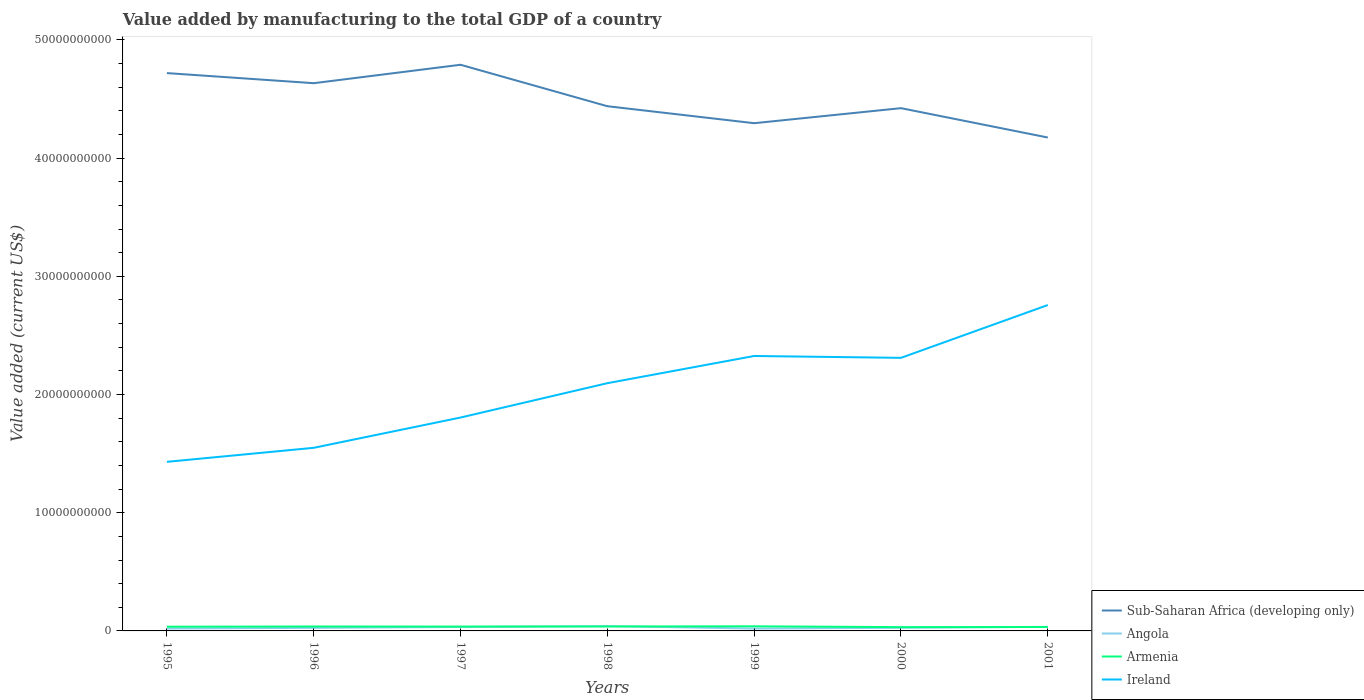Does the line corresponding to Armenia intersect with the line corresponding to Ireland?
Give a very brief answer. No. Across all years, what is the maximum value added by manufacturing to the total GDP in Sub-Saharan Africa (developing only)?
Your response must be concise. 4.17e+1. In which year was the value added by manufacturing to the total GDP in Sub-Saharan Africa (developing only) maximum?
Your answer should be compact. 2001. What is the total value added by manufacturing to the total GDP in Angola in the graph?
Keep it short and to the point. -5.66e+07. What is the difference between the highest and the second highest value added by manufacturing to the total GDP in Sub-Saharan Africa (developing only)?
Provide a succinct answer. 6.16e+09. Is the value added by manufacturing to the total GDP in Angola strictly greater than the value added by manufacturing to the total GDP in Armenia over the years?
Keep it short and to the point. No. How many years are there in the graph?
Give a very brief answer. 7. Does the graph contain any zero values?
Give a very brief answer. No. Does the graph contain grids?
Provide a short and direct response. No. How many legend labels are there?
Offer a terse response. 4. What is the title of the graph?
Your answer should be very brief. Value added by manufacturing to the total GDP of a country. What is the label or title of the Y-axis?
Give a very brief answer. Value added (current US$). What is the Value added (current US$) of Sub-Saharan Africa (developing only) in 1995?
Ensure brevity in your answer.  4.72e+1. What is the Value added (current US$) in Angola in 1995?
Provide a short and direct response. 2.03e+08. What is the Value added (current US$) of Armenia in 1995?
Your answer should be very brief. 3.56e+08. What is the Value added (current US$) in Ireland in 1995?
Keep it short and to the point. 1.43e+1. What is the Value added (current US$) in Sub-Saharan Africa (developing only) in 1996?
Your answer should be compact. 4.63e+1. What is the Value added (current US$) in Angola in 1996?
Provide a short and direct response. 2.59e+08. What is the Value added (current US$) of Armenia in 1996?
Your answer should be very brief. 3.74e+08. What is the Value added (current US$) of Ireland in 1996?
Offer a very short reply. 1.55e+1. What is the Value added (current US$) in Sub-Saharan Africa (developing only) in 1997?
Offer a terse response. 4.79e+1. What is the Value added (current US$) in Angola in 1997?
Provide a short and direct response. 3.35e+08. What is the Value added (current US$) in Armenia in 1997?
Keep it short and to the point. 3.68e+08. What is the Value added (current US$) of Ireland in 1997?
Ensure brevity in your answer.  1.81e+1. What is the Value added (current US$) of Sub-Saharan Africa (developing only) in 1998?
Give a very brief answer. 4.44e+1. What is the Value added (current US$) of Angola in 1998?
Offer a terse response. 4.07e+08. What is the Value added (current US$) of Armenia in 1998?
Keep it short and to the point. 3.77e+08. What is the Value added (current US$) of Ireland in 1998?
Give a very brief answer. 2.10e+1. What is the Value added (current US$) of Sub-Saharan Africa (developing only) in 1999?
Offer a terse response. 4.30e+1. What is the Value added (current US$) of Angola in 1999?
Give a very brief answer. 1.98e+08. What is the Value added (current US$) in Armenia in 1999?
Your response must be concise. 3.90e+08. What is the Value added (current US$) of Ireland in 1999?
Your response must be concise. 2.33e+1. What is the Value added (current US$) of Sub-Saharan Africa (developing only) in 2000?
Keep it short and to the point. 4.42e+1. What is the Value added (current US$) in Angola in 2000?
Offer a very short reply. 2.64e+08. What is the Value added (current US$) of Armenia in 2000?
Make the answer very short. 3.22e+08. What is the Value added (current US$) of Ireland in 2000?
Make the answer very short. 2.31e+1. What is the Value added (current US$) of Sub-Saharan Africa (developing only) in 2001?
Offer a terse response. 4.17e+1. What is the Value added (current US$) in Angola in 2001?
Offer a very short reply. 3.46e+08. What is the Value added (current US$) in Armenia in 2001?
Keep it short and to the point. 3.32e+08. What is the Value added (current US$) in Ireland in 2001?
Provide a short and direct response. 2.76e+1. Across all years, what is the maximum Value added (current US$) of Sub-Saharan Africa (developing only)?
Offer a very short reply. 4.79e+1. Across all years, what is the maximum Value added (current US$) of Angola?
Offer a very short reply. 4.07e+08. Across all years, what is the maximum Value added (current US$) in Armenia?
Provide a succinct answer. 3.90e+08. Across all years, what is the maximum Value added (current US$) of Ireland?
Keep it short and to the point. 2.76e+1. Across all years, what is the minimum Value added (current US$) in Sub-Saharan Africa (developing only)?
Give a very brief answer. 4.17e+1. Across all years, what is the minimum Value added (current US$) of Angola?
Your answer should be compact. 1.98e+08. Across all years, what is the minimum Value added (current US$) of Armenia?
Your response must be concise. 3.22e+08. Across all years, what is the minimum Value added (current US$) of Ireland?
Provide a short and direct response. 1.43e+1. What is the total Value added (current US$) of Sub-Saharan Africa (developing only) in the graph?
Offer a very short reply. 3.15e+11. What is the total Value added (current US$) of Angola in the graph?
Ensure brevity in your answer.  2.01e+09. What is the total Value added (current US$) in Armenia in the graph?
Your response must be concise. 2.52e+09. What is the total Value added (current US$) of Ireland in the graph?
Ensure brevity in your answer.  1.43e+11. What is the difference between the Value added (current US$) of Sub-Saharan Africa (developing only) in 1995 and that in 1996?
Provide a succinct answer. 8.54e+08. What is the difference between the Value added (current US$) of Angola in 1995 and that in 1996?
Make the answer very short. -5.66e+07. What is the difference between the Value added (current US$) in Armenia in 1995 and that in 1996?
Offer a terse response. -1.78e+07. What is the difference between the Value added (current US$) in Ireland in 1995 and that in 1996?
Your answer should be compact. -1.19e+09. What is the difference between the Value added (current US$) of Sub-Saharan Africa (developing only) in 1995 and that in 1997?
Offer a terse response. -7.05e+08. What is the difference between the Value added (current US$) in Angola in 1995 and that in 1997?
Offer a terse response. -1.32e+08. What is the difference between the Value added (current US$) of Armenia in 1995 and that in 1997?
Offer a very short reply. -1.19e+07. What is the difference between the Value added (current US$) of Ireland in 1995 and that in 1997?
Offer a terse response. -3.75e+09. What is the difference between the Value added (current US$) of Sub-Saharan Africa (developing only) in 1995 and that in 1998?
Ensure brevity in your answer.  2.80e+09. What is the difference between the Value added (current US$) of Angola in 1995 and that in 1998?
Ensure brevity in your answer.  -2.04e+08. What is the difference between the Value added (current US$) in Armenia in 1995 and that in 1998?
Keep it short and to the point. -2.03e+07. What is the difference between the Value added (current US$) of Ireland in 1995 and that in 1998?
Offer a terse response. -6.65e+09. What is the difference between the Value added (current US$) of Sub-Saharan Africa (developing only) in 1995 and that in 1999?
Keep it short and to the point. 4.24e+09. What is the difference between the Value added (current US$) in Angola in 1995 and that in 1999?
Provide a short and direct response. 4.48e+06. What is the difference between the Value added (current US$) of Armenia in 1995 and that in 1999?
Provide a succinct answer. -3.41e+07. What is the difference between the Value added (current US$) in Ireland in 1995 and that in 1999?
Offer a very short reply. -8.96e+09. What is the difference between the Value added (current US$) of Sub-Saharan Africa (developing only) in 1995 and that in 2000?
Your answer should be compact. 2.97e+09. What is the difference between the Value added (current US$) in Angola in 1995 and that in 2000?
Offer a terse response. -6.11e+07. What is the difference between the Value added (current US$) in Armenia in 1995 and that in 2000?
Ensure brevity in your answer.  3.45e+07. What is the difference between the Value added (current US$) of Ireland in 1995 and that in 2000?
Provide a succinct answer. -8.80e+09. What is the difference between the Value added (current US$) of Sub-Saharan Africa (developing only) in 1995 and that in 2001?
Your answer should be compact. 5.45e+09. What is the difference between the Value added (current US$) of Angola in 1995 and that in 2001?
Make the answer very short. -1.43e+08. What is the difference between the Value added (current US$) of Armenia in 1995 and that in 2001?
Provide a short and direct response. 2.42e+07. What is the difference between the Value added (current US$) in Ireland in 1995 and that in 2001?
Keep it short and to the point. -1.33e+1. What is the difference between the Value added (current US$) of Sub-Saharan Africa (developing only) in 1996 and that in 1997?
Provide a succinct answer. -1.56e+09. What is the difference between the Value added (current US$) of Angola in 1996 and that in 1997?
Your response must be concise. -7.56e+07. What is the difference between the Value added (current US$) in Armenia in 1996 and that in 1997?
Your answer should be compact. 5.88e+06. What is the difference between the Value added (current US$) in Ireland in 1996 and that in 1997?
Give a very brief answer. -2.56e+09. What is the difference between the Value added (current US$) in Sub-Saharan Africa (developing only) in 1996 and that in 1998?
Give a very brief answer. 1.95e+09. What is the difference between the Value added (current US$) in Angola in 1996 and that in 1998?
Ensure brevity in your answer.  -1.48e+08. What is the difference between the Value added (current US$) of Armenia in 1996 and that in 1998?
Offer a very short reply. -2.52e+06. What is the difference between the Value added (current US$) of Ireland in 1996 and that in 1998?
Provide a short and direct response. -5.47e+09. What is the difference between the Value added (current US$) in Sub-Saharan Africa (developing only) in 1996 and that in 1999?
Make the answer very short. 3.38e+09. What is the difference between the Value added (current US$) of Angola in 1996 and that in 1999?
Offer a very short reply. 6.11e+07. What is the difference between the Value added (current US$) in Armenia in 1996 and that in 1999?
Your response must be concise. -1.63e+07. What is the difference between the Value added (current US$) of Ireland in 1996 and that in 1999?
Keep it short and to the point. -7.77e+09. What is the difference between the Value added (current US$) in Sub-Saharan Africa (developing only) in 1996 and that in 2000?
Provide a succinct answer. 2.11e+09. What is the difference between the Value added (current US$) in Angola in 1996 and that in 2000?
Offer a very short reply. -4.50e+06. What is the difference between the Value added (current US$) of Armenia in 1996 and that in 2000?
Your answer should be very brief. 5.23e+07. What is the difference between the Value added (current US$) of Ireland in 1996 and that in 2000?
Your response must be concise. -7.61e+09. What is the difference between the Value added (current US$) of Sub-Saharan Africa (developing only) in 1996 and that in 2001?
Offer a terse response. 4.60e+09. What is the difference between the Value added (current US$) in Angola in 1996 and that in 2001?
Your answer should be compact. -8.67e+07. What is the difference between the Value added (current US$) in Armenia in 1996 and that in 2001?
Provide a short and direct response. 4.20e+07. What is the difference between the Value added (current US$) in Ireland in 1996 and that in 2001?
Your response must be concise. -1.21e+1. What is the difference between the Value added (current US$) in Sub-Saharan Africa (developing only) in 1997 and that in 1998?
Ensure brevity in your answer.  3.51e+09. What is the difference between the Value added (current US$) of Angola in 1997 and that in 1998?
Your answer should be very brief. -7.23e+07. What is the difference between the Value added (current US$) of Armenia in 1997 and that in 1998?
Your answer should be very brief. -8.41e+06. What is the difference between the Value added (current US$) of Ireland in 1997 and that in 1998?
Offer a terse response. -2.91e+09. What is the difference between the Value added (current US$) in Sub-Saharan Africa (developing only) in 1997 and that in 1999?
Provide a short and direct response. 4.94e+09. What is the difference between the Value added (current US$) in Angola in 1997 and that in 1999?
Your response must be concise. 1.37e+08. What is the difference between the Value added (current US$) of Armenia in 1997 and that in 1999?
Your answer should be very brief. -2.22e+07. What is the difference between the Value added (current US$) of Ireland in 1997 and that in 1999?
Make the answer very short. -5.21e+09. What is the difference between the Value added (current US$) in Sub-Saharan Africa (developing only) in 1997 and that in 2000?
Offer a terse response. 3.67e+09. What is the difference between the Value added (current US$) in Angola in 1997 and that in 2000?
Offer a very short reply. 7.11e+07. What is the difference between the Value added (current US$) in Armenia in 1997 and that in 2000?
Your answer should be compact. 4.64e+07. What is the difference between the Value added (current US$) of Ireland in 1997 and that in 2000?
Keep it short and to the point. -5.05e+09. What is the difference between the Value added (current US$) in Sub-Saharan Africa (developing only) in 1997 and that in 2001?
Make the answer very short. 6.16e+09. What is the difference between the Value added (current US$) in Angola in 1997 and that in 2001?
Give a very brief answer. -1.12e+07. What is the difference between the Value added (current US$) of Armenia in 1997 and that in 2001?
Give a very brief answer. 3.61e+07. What is the difference between the Value added (current US$) of Ireland in 1997 and that in 2001?
Keep it short and to the point. -9.52e+09. What is the difference between the Value added (current US$) in Sub-Saharan Africa (developing only) in 1998 and that in 1999?
Your response must be concise. 1.44e+09. What is the difference between the Value added (current US$) of Angola in 1998 and that in 1999?
Your answer should be very brief. 2.09e+08. What is the difference between the Value added (current US$) in Armenia in 1998 and that in 1999?
Keep it short and to the point. -1.38e+07. What is the difference between the Value added (current US$) of Ireland in 1998 and that in 1999?
Your answer should be compact. -2.30e+09. What is the difference between the Value added (current US$) in Sub-Saharan Africa (developing only) in 1998 and that in 2000?
Make the answer very short. 1.66e+08. What is the difference between the Value added (current US$) in Angola in 1998 and that in 2000?
Your response must be concise. 1.43e+08. What is the difference between the Value added (current US$) in Armenia in 1998 and that in 2000?
Your answer should be compact. 5.48e+07. What is the difference between the Value added (current US$) of Ireland in 1998 and that in 2000?
Give a very brief answer. -2.14e+09. What is the difference between the Value added (current US$) of Sub-Saharan Africa (developing only) in 1998 and that in 2001?
Keep it short and to the point. 2.65e+09. What is the difference between the Value added (current US$) of Angola in 1998 and that in 2001?
Give a very brief answer. 6.12e+07. What is the difference between the Value added (current US$) of Armenia in 1998 and that in 2001?
Your answer should be compact. 4.45e+07. What is the difference between the Value added (current US$) of Ireland in 1998 and that in 2001?
Offer a terse response. -6.61e+09. What is the difference between the Value added (current US$) of Sub-Saharan Africa (developing only) in 1999 and that in 2000?
Offer a terse response. -1.27e+09. What is the difference between the Value added (current US$) in Angola in 1999 and that in 2000?
Your response must be concise. -6.56e+07. What is the difference between the Value added (current US$) of Armenia in 1999 and that in 2000?
Make the answer very short. 6.86e+07. What is the difference between the Value added (current US$) in Ireland in 1999 and that in 2000?
Your answer should be compact. 1.57e+08. What is the difference between the Value added (current US$) of Sub-Saharan Africa (developing only) in 1999 and that in 2001?
Ensure brevity in your answer.  1.21e+09. What is the difference between the Value added (current US$) in Angola in 1999 and that in 2001?
Give a very brief answer. -1.48e+08. What is the difference between the Value added (current US$) of Armenia in 1999 and that in 2001?
Offer a terse response. 5.83e+07. What is the difference between the Value added (current US$) in Ireland in 1999 and that in 2001?
Make the answer very short. -4.31e+09. What is the difference between the Value added (current US$) in Sub-Saharan Africa (developing only) in 2000 and that in 2001?
Offer a terse response. 2.48e+09. What is the difference between the Value added (current US$) of Angola in 2000 and that in 2001?
Offer a terse response. -8.22e+07. What is the difference between the Value added (current US$) of Armenia in 2000 and that in 2001?
Keep it short and to the point. -1.03e+07. What is the difference between the Value added (current US$) of Ireland in 2000 and that in 2001?
Your answer should be very brief. -4.47e+09. What is the difference between the Value added (current US$) of Sub-Saharan Africa (developing only) in 1995 and the Value added (current US$) of Angola in 1996?
Your answer should be compact. 4.69e+1. What is the difference between the Value added (current US$) of Sub-Saharan Africa (developing only) in 1995 and the Value added (current US$) of Armenia in 1996?
Provide a succinct answer. 4.68e+1. What is the difference between the Value added (current US$) in Sub-Saharan Africa (developing only) in 1995 and the Value added (current US$) in Ireland in 1996?
Your answer should be very brief. 3.17e+1. What is the difference between the Value added (current US$) of Angola in 1995 and the Value added (current US$) of Armenia in 1996?
Give a very brief answer. -1.71e+08. What is the difference between the Value added (current US$) in Angola in 1995 and the Value added (current US$) in Ireland in 1996?
Your response must be concise. -1.53e+1. What is the difference between the Value added (current US$) in Armenia in 1995 and the Value added (current US$) in Ireland in 1996?
Your answer should be compact. -1.51e+1. What is the difference between the Value added (current US$) in Sub-Saharan Africa (developing only) in 1995 and the Value added (current US$) in Angola in 1997?
Provide a short and direct response. 4.69e+1. What is the difference between the Value added (current US$) in Sub-Saharan Africa (developing only) in 1995 and the Value added (current US$) in Armenia in 1997?
Give a very brief answer. 4.68e+1. What is the difference between the Value added (current US$) of Sub-Saharan Africa (developing only) in 1995 and the Value added (current US$) of Ireland in 1997?
Your response must be concise. 2.91e+1. What is the difference between the Value added (current US$) of Angola in 1995 and the Value added (current US$) of Armenia in 1997?
Make the answer very short. -1.65e+08. What is the difference between the Value added (current US$) of Angola in 1995 and the Value added (current US$) of Ireland in 1997?
Give a very brief answer. -1.79e+1. What is the difference between the Value added (current US$) in Armenia in 1995 and the Value added (current US$) in Ireland in 1997?
Provide a succinct answer. -1.77e+1. What is the difference between the Value added (current US$) of Sub-Saharan Africa (developing only) in 1995 and the Value added (current US$) of Angola in 1998?
Make the answer very short. 4.68e+1. What is the difference between the Value added (current US$) of Sub-Saharan Africa (developing only) in 1995 and the Value added (current US$) of Armenia in 1998?
Provide a short and direct response. 4.68e+1. What is the difference between the Value added (current US$) of Sub-Saharan Africa (developing only) in 1995 and the Value added (current US$) of Ireland in 1998?
Make the answer very short. 2.62e+1. What is the difference between the Value added (current US$) of Angola in 1995 and the Value added (current US$) of Armenia in 1998?
Keep it short and to the point. -1.74e+08. What is the difference between the Value added (current US$) in Angola in 1995 and the Value added (current US$) in Ireland in 1998?
Ensure brevity in your answer.  -2.08e+1. What is the difference between the Value added (current US$) of Armenia in 1995 and the Value added (current US$) of Ireland in 1998?
Give a very brief answer. -2.06e+1. What is the difference between the Value added (current US$) in Sub-Saharan Africa (developing only) in 1995 and the Value added (current US$) in Angola in 1999?
Offer a very short reply. 4.70e+1. What is the difference between the Value added (current US$) in Sub-Saharan Africa (developing only) in 1995 and the Value added (current US$) in Armenia in 1999?
Give a very brief answer. 4.68e+1. What is the difference between the Value added (current US$) in Sub-Saharan Africa (developing only) in 1995 and the Value added (current US$) in Ireland in 1999?
Your response must be concise. 2.39e+1. What is the difference between the Value added (current US$) of Angola in 1995 and the Value added (current US$) of Armenia in 1999?
Keep it short and to the point. -1.88e+08. What is the difference between the Value added (current US$) of Angola in 1995 and the Value added (current US$) of Ireland in 1999?
Provide a short and direct response. -2.31e+1. What is the difference between the Value added (current US$) in Armenia in 1995 and the Value added (current US$) in Ireland in 1999?
Keep it short and to the point. -2.29e+1. What is the difference between the Value added (current US$) in Sub-Saharan Africa (developing only) in 1995 and the Value added (current US$) in Angola in 2000?
Offer a very short reply. 4.69e+1. What is the difference between the Value added (current US$) in Sub-Saharan Africa (developing only) in 1995 and the Value added (current US$) in Armenia in 2000?
Ensure brevity in your answer.  4.69e+1. What is the difference between the Value added (current US$) in Sub-Saharan Africa (developing only) in 1995 and the Value added (current US$) in Ireland in 2000?
Ensure brevity in your answer.  2.41e+1. What is the difference between the Value added (current US$) in Angola in 1995 and the Value added (current US$) in Armenia in 2000?
Give a very brief answer. -1.19e+08. What is the difference between the Value added (current US$) of Angola in 1995 and the Value added (current US$) of Ireland in 2000?
Your answer should be very brief. -2.29e+1. What is the difference between the Value added (current US$) in Armenia in 1995 and the Value added (current US$) in Ireland in 2000?
Your answer should be compact. -2.27e+1. What is the difference between the Value added (current US$) in Sub-Saharan Africa (developing only) in 1995 and the Value added (current US$) in Angola in 2001?
Offer a very short reply. 4.69e+1. What is the difference between the Value added (current US$) in Sub-Saharan Africa (developing only) in 1995 and the Value added (current US$) in Armenia in 2001?
Offer a terse response. 4.69e+1. What is the difference between the Value added (current US$) in Sub-Saharan Africa (developing only) in 1995 and the Value added (current US$) in Ireland in 2001?
Make the answer very short. 1.96e+1. What is the difference between the Value added (current US$) of Angola in 1995 and the Value added (current US$) of Armenia in 2001?
Your response must be concise. -1.29e+08. What is the difference between the Value added (current US$) of Angola in 1995 and the Value added (current US$) of Ireland in 2001?
Provide a succinct answer. -2.74e+1. What is the difference between the Value added (current US$) in Armenia in 1995 and the Value added (current US$) in Ireland in 2001?
Your answer should be compact. -2.72e+1. What is the difference between the Value added (current US$) of Sub-Saharan Africa (developing only) in 1996 and the Value added (current US$) of Angola in 1997?
Offer a very short reply. 4.60e+1. What is the difference between the Value added (current US$) in Sub-Saharan Africa (developing only) in 1996 and the Value added (current US$) in Armenia in 1997?
Your response must be concise. 4.60e+1. What is the difference between the Value added (current US$) in Sub-Saharan Africa (developing only) in 1996 and the Value added (current US$) in Ireland in 1997?
Keep it short and to the point. 2.83e+1. What is the difference between the Value added (current US$) of Angola in 1996 and the Value added (current US$) of Armenia in 1997?
Offer a very short reply. -1.09e+08. What is the difference between the Value added (current US$) in Angola in 1996 and the Value added (current US$) in Ireland in 1997?
Your answer should be compact. -1.78e+1. What is the difference between the Value added (current US$) of Armenia in 1996 and the Value added (current US$) of Ireland in 1997?
Your response must be concise. -1.77e+1. What is the difference between the Value added (current US$) in Sub-Saharan Africa (developing only) in 1996 and the Value added (current US$) in Angola in 1998?
Offer a very short reply. 4.59e+1. What is the difference between the Value added (current US$) in Sub-Saharan Africa (developing only) in 1996 and the Value added (current US$) in Armenia in 1998?
Your answer should be very brief. 4.60e+1. What is the difference between the Value added (current US$) of Sub-Saharan Africa (developing only) in 1996 and the Value added (current US$) of Ireland in 1998?
Your response must be concise. 2.54e+1. What is the difference between the Value added (current US$) of Angola in 1996 and the Value added (current US$) of Armenia in 1998?
Keep it short and to the point. -1.17e+08. What is the difference between the Value added (current US$) in Angola in 1996 and the Value added (current US$) in Ireland in 1998?
Provide a short and direct response. -2.07e+1. What is the difference between the Value added (current US$) in Armenia in 1996 and the Value added (current US$) in Ireland in 1998?
Provide a short and direct response. -2.06e+1. What is the difference between the Value added (current US$) in Sub-Saharan Africa (developing only) in 1996 and the Value added (current US$) in Angola in 1999?
Provide a succinct answer. 4.61e+1. What is the difference between the Value added (current US$) of Sub-Saharan Africa (developing only) in 1996 and the Value added (current US$) of Armenia in 1999?
Your answer should be compact. 4.60e+1. What is the difference between the Value added (current US$) of Sub-Saharan Africa (developing only) in 1996 and the Value added (current US$) of Ireland in 1999?
Your response must be concise. 2.31e+1. What is the difference between the Value added (current US$) of Angola in 1996 and the Value added (current US$) of Armenia in 1999?
Your answer should be compact. -1.31e+08. What is the difference between the Value added (current US$) in Angola in 1996 and the Value added (current US$) in Ireland in 1999?
Provide a succinct answer. -2.30e+1. What is the difference between the Value added (current US$) in Armenia in 1996 and the Value added (current US$) in Ireland in 1999?
Your answer should be compact. -2.29e+1. What is the difference between the Value added (current US$) in Sub-Saharan Africa (developing only) in 1996 and the Value added (current US$) in Angola in 2000?
Your response must be concise. 4.61e+1. What is the difference between the Value added (current US$) of Sub-Saharan Africa (developing only) in 1996 and the Value added (current US$) of Armenia in 2000?
Keep it short and to the point. 4.60e+1. What is the difference between the Value added (current US$) of Sub-Saharan Africa (developing only) in 1996 and the Value added (current US$) of Ireland in 2000?
Offer a terse response. 2.32e+1. What is the difference between the Value added (current US$) in Angola in 1996 and the Value added (current US$) in Armenia in 2000?
Your answer should be very brief. -6.25e+07. What is the difference between the Value added (current US$) of Angola in 1996 and the Value added (current US$) of Ireland in 2000?
Provide a short and direct response. -2.28e+1. What is the difference between the Value added (current US$) in Armenia in 1996 and the Value added (current US$) in Ireland in 2000?
Provide a succinct answer. -2.27e+1. What is the difference between the Value added (current US$) of Sub-Saharan Africa (developing only) in 1996 and the Value added (current US$) of Angola in 2001?
Make the answer very short. 4.60e+1. What is the difference between the Value added (current US$) of Sub-Saharan Africa (developing only) in 1996 and the Value added (current US$) of Armenia in 2001?
Make the answer very short. 4.60e+1. What is the difference between the Value added (current US$) of Sub-Saharan Africa (developing only) in 1996 and the Value added (current US$) of Ireland in 2001?
Provide a succinct answer. 1.88e+1. What is the difference between the Value added (current US$) in Angola in 1996 and the Value added (current US$) in Armenia in 2001?
Offer a very short reply. -7.28e+07. What is the difference between the Value added (current US$) of Angola in 1996 and the Value added (current US$) of Ireland in 2001?
Offer a terse response. -2.73e+1. What is the difference between the Value added (current US$) of Armenia in 1996 and the Value added (current US$) of Ireland in 2001?
Offer a very short reply. -2.72e+1. What is the difference between the Value added (current US$) of Sub-Saharan Africa (developing only) in 1997 and the Value added (current US$) of Angola in 1998?
Your response must be concise. 4.75e+1. What is the difference between the Value added (current US$) of Sub-Saharan Africa (developing only) in 1997 and the Value added (current US$) of Armenia in 1998?
Make the answer very short. 4.75e+1. What is the difference between the Value added (current US$) in Sub-Saharan Africa (developing only) in 1997 and the Value added (current US$) in Ireland in 1998?
Your response must be concise. 2.69e+1. What is the difference between the Value added (current US$) of Angola in 1997 and the Value added (current US$) of Armenia in 1998?
Offer a terse response. -4.17e+07. What is the difference between the Value added (current US$) of Angola in 1997 and the Value added (current US$) of Ireland in 1998?
Make the answer very short. -2.06e+1. What is the difference between the Value added (current US$) of Armenia in 1997 and the Value added (current US$) of Ireland in 1998?
Your answer should be compact. -2.06e+1. What is the difference between the Value added (current US$) of Sub-Saharan Africa (developing only) in 1997 and the Value added (current US$) of Angola in 1999?
Your response must be concise. 4.77e+1. What is the difference between the Value added (current US$) of Sub-Saharan Africa (developing only) in 1997 and the Value added (current US$) of Armenia in 1999?
Keep it short and to the point. 4.75e+1. What is the difference between the Value added (current US$) in Sub-Saharan Africa (developing only) in 1997 and the Value added (current US$) in Ireland in 1999?
Your answer should be very brief. 2.46e+1. What is the difference between the Value added (current US$) of Angola in 1997 and the Value added (current US$) of Armenia in 1999?
Offer a very short reply. -5.55e+07. What is the difference between the Value added (current US$) of Angola in 1997 and the Value added (current US$) of Ireland in 1999?
Offer a terse response. -2.29e+1. What is the difference between the Value added (current US$) in Armenia in 1997 and the Value added (current US$) in Ireland in 1999?
Give a very brief answer. -2.29e+1. What is the difference between the Value added (current US$) in Sub-Saharan Africa (developing only) in 1997 and the Value added (current US$) in Angola in 2000?
Offer a terse response. 4.76e+1. What is the difference between the Value added (current US$) in Sub-Saharan Africa (developing only) in 1997 and the Value added (current US$) in Armenia in 2000?
Make the answer very short. 4.76e+1. What is the difference between the Value added (current US$) of Sub-Saharan Africa (developing only) in 1997 and the Value added (current US$) of Ireland in 2000?
Provide a short and direct response. 2.48e+1. What is the difference between the Value added (current US$) of Angola in 1997 and the Value added (current US$) of Armenia in 2000?
Your response must be concise. 1.31e+07. What is the difference between the Value added (current US$) of Angola in 1997 and the Value added (current US$) of Ireland in 2000?
Offer a very short reply. -2.28e+1. What is the difference between the Value added (current US$) in Armenia in 1997 and the Value added (current US$) in Ireland in 2000?
Your response must be concise. -2.27e+1. What is the difference between the Value added (current US$) in Sub-Saharan Africa (developing only) in 1997 and the Value added (current US$) in Angola in 2001?
Offer a very short reply. 4.76e+1. What is the difference between the Value added (current US$) of Sub-Saharan Africa (developing only) in 1997 and the Value added (current US$) of Armenia in 2001?
Provide a short and direct response. 4.76e+1. What is the difference between the Value added (current US$) in Sub-Saharan Africa (developing only) in 1997 and the Value added (current US$) in Ireland in 2001?
Offer a terse response. 2.03e+1. What is the difference between the Value added (current US$) in Angola in 1997 and the Value added (current US$) in Armenia in 2001?
Give a very brief answer. 2.81e+06. What is the difference between the Value added (current US$) in Angola in 1997 and the Value added (current US$) in Ireland in 2001?
Your answer should be very brief. -2.72e+1. What is the difference between the Value added (current US$) in Armenia in 1997 and the Value added (current US$) in Ireland in 2001?
Offer a terse response. -2.72e+1. What is the difference between the Value added (current US$) of Sub-Saharan Africa (developing only) in 1998 and the Value added (current US$) of Angola in 1999?
Ensure brevity in your answer.  4.42e+1. What is the difference between the Value added (current US$) of Sub-Saharan Africa (developing only) in 1998 and the Value added (current US$) of Armenia in 1999?
Offer a very short reply. 4.40e+1. What is the difference between the Value added (current US$) in Sub-Saharan Africa (developing only) in 1998 and the Value added (current US$) in Ireland in 1999?
Offer a terse response. 2.11e+1. What is the difference between the Value added (current US$) of Angola in 1998 and the Value added (current US$) of Armenia in 1999?
Give a very brief answer. 1.68e+07. What is the difference between the Value added (current US$) in Angola in 1998 and the Value added (current US$) in Ireland in 1999?
Keep it short and to the point. -2.29e+1. What is the difference between the Value added (current US$) of Armenia in 1998 and the Value added (current US$) of Ireland in 1999?
Your response must be concise. -2.29e+1. What is the difference between the Value added (current US$) of Sub-Saharan Africa (developing only) in 1998 and the Value added (current US$) of Angola in 2000?
Your answer should be compact. 4.41e+1. What is the difference between the Value added (current US$) in Sub-Saharan Africa (developing only) in 1998 and the Value added (current US$) in Armenia in 2000?
Your response must be concise. 4.41e+1. What is the difference between the Value added (current US$) of Sub-Saharan Africa (developing only) in 1998 and the Value added (current US$) of Ireland in 2000?
Your answer should be compact. 2.13e+1. What is the difference between the Value added (current US$) of Angola in 1998 and the Value added (current US$) of Armenia in 2000?
Give a very brief answer. 8.54e+07. What is the difference between the Value added (current US$) in Angola in 1998 and the Value added (current US$) in Ireland in 2000?
Keep it short and to the point. -2.27e+1. What is the difference between the Value added (current US$) of Armenia in 1998 and the Value added (current US$) of Ireland in 2000?
Offer a terse response. -2.27e+1. What is the difference between the Value added (current US$) in Sub-Saharan Africa (developing only) in 1998 and the Value added (current US$) in Angola in 2001?
Keep it short and to the point. 4.41e+1. What is the difference between the Value added (current US$) in Sub-Saharan Africa (developing only) in 1998 and the Value added (current US$) in Armenia in 2001?
Give a very brief answer. 4.41e+1. What is the difference between the Value added (current US$) of Sub-Saharan Africa (developing only) in 1998 and the Value added (current US$) of Ireland in 2001?
Make the answer very short. 1.68e+1. What is the difference between the Value added (current US$) of Angola in 1998 and the Value added (current US$) of Armenia in 2001?
Provide a succinct answer. 7.51e+07. What is the difference between the Value added (current US$) of Angola in 1998 and the Value added (current US$) of Ireland in 2001?
Offer a terse response. -2.72e+1. What is the difference between the Value added (current US$) of Armenia in 1998 and the Value added (current US$) of Ireland in 2001?
Keep it short and to the point. -2.72e+1. What is the difference between the Value added (current US$) of Sub-Saharan Africa (developing only) in 1999 and the Value added (current US$) of Angola in 2000?
Provide a short and direct response. 4.27e+1. What is the difference between the Value added (current US$) in Sub-Saharan Africa (developing only) in 1999 and the Value added (current US$) in Armenia in 2000?
Your answer should be very brief. 4.26e+1. What is the difference between the Value added (current US$) of Sub-Saharan Africa (developing only) in 1999 and the Value added (current US$) of Ireland in 2000?
Ensure brevity in your answer.  1.99e+1. What is the difference between the Value added (current US$) in Angola in 1999 and the Value added (current US$) in Armenia in 2000?
Offer a terse response. -1.24e+08. What is the difference between the Value added (current US$) of Angola in 1999 and the Value added (current US$) of Ireland in 2000?
Offer a terse response. -2.29e+1. What is the difference between the Value added (current US$) in Armenia in 1999 and the Value added (current US$) in Ireland in 2000?
Your answer should be compact. -2.27e+1. What is the difference between the Value added (current US$) of Sub-Saharan Africa (developing only) in 1999 and the Value added (current US$) of Angola in 2001?
Keep it short and to the point. 4.26e+1. What is the difference between the Value added (current US$) in Sub-Saharan Africa (developing only) in 1999 and the Value added (current US$) in Armenia in 2001?
Make the answer very short. 4.26e+1. What is the difference between the Value added (current US$) of Sub-Saharan Africa (developing only) in 1999 and the Value added (current US$) of Ireland in 2001?
Offer a very short reply. 1.54e+1. What is the difference between the Value added (current US$) in Angola in 1999 and the Value added (current US$) in Armenia in 2001?
Offer a terse response. -1.34e+08. What is the difference between the Value added (current US$) in Angola in 1999 and the Value added (current US$) in Ireland in 2001?
Provide a succinct answer. -2.74e+1. What is the difference between the Value added (current US$) of Armenia in 1999 and the Value added (current US$) of Ireland in 2001?
Your answer should be compact. -2.72e+1. What is the difference between the Value added (current US$) in Sub-Saharan Africa (developing only) in 2000 and the Value added (current US$) in Angola in 2001?
Offer a terse response. 4.39e+1. What is the difference between the Value added (current US$) in Sub-Saharan Africa (developing only) in 2000 and the Value added (current US$) in Armenia in 2001?
Your answer should be compact. 4.39e+1. What is the difference between the Value added (current US$) in Sub-Saharan Africa (developing only) in 2000 and the Value added (current US$) in Ireland in 2001?
Offer a terse response. 1.67e+1. What is the difference between the Value added (current US$) in Angola in 2000 and the Value added (current US$) in Armenia in 2001?
Your response must be concise. -6.83e+07. What is the difference between the Value added (current US$) in Angola in 2000 and the Value added (current US$) in Ireland in 2001?
Make the answer very short. -2.73e+1. What is the difference between the Value added (current US$) of Armenia in 2000 and the Value added (current US$) of Ireland in 2001?
Provide a short and direct response. -2.73e+1. What is the average Value added (current US$) of Sub-Saharan Africa (developing only) per year?
Ensure brevity in your answer.  4.50e+1. What is the average Value added (current US$) of Angola per year?
Keep it short and to the point. 2.88e+08. What is the average Value added (current US$) in Armenia per year?
Keep it short and to the point. 3.60e+08. What is the average Value added (current US$) in Ireland per year?
Provide a short and direct response. 2.04e+1. In the year 1995, what is the difference between the Value added (current US$) in Sub-Saharan Africa (developing only) and Value added (current US$) in Angola?
Provide a succinct answer. 4.70e+1. In the year 1995, what is the difference between the Value added (current US$) of Sub-Saharan Africa (developing only) and Value added (current US$) of Armenia?
Your response must be concise. 4.68e+1. In the year 1995, what is the difference between the Value added (current US$) in Sub-Saharan Africa (developing only) and Value added (current US$) in Ireland?
Offer a very short reply. 3.29e+1. In the year 1995, what is the difference between the Value added (current US$) of Angola and Value added (current US$) of Armenia?
Offer a very short reply. -1.54e+08. In the year 1995, what is the difference between the Value added (current US$) in Angola and Value added (current US$) in Ireland?
Provide a short and direct response. -1.41e+1. In the year 1995, what is the difference between the Value added (current US$) in Armenia and Value added (current US$) in Ireland?
Your response must be concise. -1.40e+1. In the year 1996, what is the difference between the Value added (current US$) in Sub-Saharan Africa (developing only) and Value added (current US$) in Angola?
Provide a short and direct response. 4.61e+1. In the year 1996, what is the difference between the Value added (current US$) of Sub-Saharan Africa (developing only) and Value added (current US$) of Armenia?
Keep it short and to the point. 4.60e+1. In the year 1996, what is the difference between the Value added (current US$) in Sub-Saharan Africa (developing only) and Value added (current US$) in Ireland?
Keep it short and to the point. 3.09e+1. In the year 1996, what is the difference between the Value added (current US$) in Angola and Value added (current US$) in Armenia?
Give a very brief answer. -1.15e+08. In the year 1996, what is the difference between the Value added (current US$) of Angola and Value added (current US$) of Ireland?
Keep it short and to the point. -1.52e+1. In the year 1996, what is the difference between the Value added (current US$) of Armenia and Value added (current US$) of Ireland?
Offer a terse response. -1.51e+1. In the year 1997, what is the difference between the Value added (current US$) in Sub-Saharan Africa (developing only) and Value added (current US$) in Angola?
Provide a succinct answer. 4.76e+1. In the year 1997, what is the difference between the Value added (current US$) of Sub-Saharan Africa (developing only) and Value added (current US$) of Armenia?
Make the answer very short. 4.75e+1. In the year 1997, what is the difference between the Value added (current US$) of Sub-Saharan Africa (developing only) and Value added (current US$) of Ireland?
Give a very brief answer. 2.98e+1. In the year 1997, what is the difference between the Value added (current US$) of Angola and Value added (current US$) of Armenia?
Offer a very short reply. -3.33e+07. In the year 1997, what is the difference between the Value added (current US$) in Angola and Value added (current US$) in Ireland?
Your answer should be compact. -1.77e+1. In the year 1997, what is the difference between the Value added (current US$) in Armenia and Value added (current US$) in Ireland?
Offer a very short reply. -1.77e+1. In the year 1998, what is the difference between the Value added (current US$) of Sub-Saharan Africa (developing only) and Value added (current US$) of Angola?
Ensure brevity in your answer.  4.40e+1. In the year 1998, what is the difference between the Value added (current US$) of Sub-Saharan Africa (developing only) and Value added (current US$) of Armenia?
Keep it short and to the point. 4.40e+1. In the year 1998, what is the difference between the Value added (current US$) of Sub-Saharan Africa (developing only) and Value added (current US$) of Ireland?
Your answer should be compact. 2.34e+1. In the year 1998, what is the difference between the Value added (current US$) of Angola and Value added (current US$) of Armenia?
Your answer should be compact. 3.06e+07. In the year 1998, what is the difference between the Value added (current US$) in Angola and Value added (current US$) in Ireland?
Offer a terse response. -2.06e+1. In the year 1998, what is the difference between the Value added (current US$) of Armenia and Value added (current US$) of Ireland?
Make the answer very short. -2.06e+1. In the year 1999, what is the difference between the Value added (current US$) in Sub-Saharan Africa (developing only) and Value added (current US$) in Angola?
Provide a succinct answer. 4.28e+1. In the year 1999, what is the difference between the Value added (current US$) of Sub-Saharan Africa (developing only) and Value added (current US$) of Armenia?
Provide a succinct answer. 4.26e+1. In the year 1999, what is the difference between the Value added (current US$) in Sub-Saharan Africa (developing only) and Value added (current US$) in Ireland?
Your response must be concise. 1.97e+1. In the year 1999, what is the difference between the Value added (current US$) in Angola and Value added (current US$) in Armenia?
Offer a terse response. -1.92e+08. In the year 1999, what is the difference between the Value added (current US$) of Angola and Value added (current US$) of Ireland?
Provide a succinct answer. -2.31e+1. In the year 1999, what is the difference between the Value added (current US$) in Armenia and Value added (current US$) in Ireland?
Offer a terse response. -2.29e+1. In the year 2000, what is the difference between the Value added (current US$) in Sub-Saharan Africa (developing only) and Value added (current US$) in Angola?
Provide a short and direct response. 4.40e+1. In the year 2000, what is the difference between the Value added (current US$) of Sub-Saharan Africa (developing only) and Value added (current US$) of Armenia?
Provide a short and direct response. 4.39e+1. In the year 2000, what is the difference between the Value added (current US$) in Sub-Saharan Africa (developing only) and Value added (current US$) in Ireland?
Your response must be concise. 2.11e+1. In the year 2000, what is the difference between the Value added (current US$) in Angola and Value added (current US$) in Armenia?
Your answer should be very brief. -5.80e+07. In the year 2000, what is the difference between the Value added (current US$) of Angola and Value added (current US$) of Ireland?
Offer a very short reply. -2.28e+1. In the year 2000, what is the difference between the Value added (current US$) of Armenia and Value added (current US$) of Ireland?
Give a very brief answer. -2.28e+1. In the year 2001, what is the difference between the Value added (current US$) in Sub-Saharan Africa (developing only) and Value added (current US$) in Angola?
Your response must be concise. 4.14e+1. In the year 2001, what is the difference between the Value added (current US$) of Sub-Saharan Africa (developing only) and Value added (current US$) of Armenia?
Provide a short and direct response. 4.14e+1. In the year 2001, what is the difference between the Value added (current US$) in Sub-Saharan Africa (developing only) and Value added (current US$) in Ireland?
Ensure brevity in your answer.  1.42e+1. In the year 2001, what is the difference between the Value added (current US$) of Angola and Value added (current US$) of Armenia?
Give a very brief answer. 1.40e+07. In the year 2001, what is the difference between the Value added (current US$) of Angola and Value added (current US$) of Ireland?
Provide a short and direct response. -2.72e+1. In the year 2001, what is the difference between the Value added (current US$) of Armenia and Value added (current US$) of Ireland?
Give a very brief answer. -2.72e+1. What is the ratio of the Value added (current US$) in Sub-Saharan Africa (developing only) in 1995 to that in 1996?
Make the answer very short. 1.02. What is the ratio of the Value added (current US$) of Angola in 1995 to that in 1996?
Offer a very short reply. 0.78. What is the ratio of the Value added (current US$) of Ireland in 1995 to that in 1996?
Your answer should be compact. 0.92. What is the ratio of the Value added (current US$) in Angola in 1995 to that in 1997?
Make the answer very short. 0.61. What is the ratio of the Value added (current US$) in Armenia in 1995 to that in 1997?
Make the answer very short. 0.97. What is the ratio of the Value added (current US$) of Ireland in 1995 to that in 1997?
Offer a very short reply. 0.79. What is the ratio of the Value added (current US$) of Sub-Saharan Africa (developing only) in 1995 to that in 1998?
Offer a terse response. 1.06. What is the ratio of the Value added (current US$) in Angola in 1995 to that in 1998?
Give a very brief answer. 0.5. What is the ratio of the Value added (current US$) in Armenia in 1995 to that in 1998?
Ensure brevity in your answer.  0.95. What is the ratio of the Value added (current US$) in Ireland in 1995 to that in 1998?
Make the answer very short. 0.68. What is the ratio of the Value added (current US$) of Sub-Saharan Africa (developing only) in 1995 to that in 1999?
Offer a very short reply. 1.1. What is the ratio of the Value added (current US$) in Angola in 1995 to that in 1999?
Your answer should be very brief. 1.02. What is the ratio of the Value added (current US$) of Armenia in 1995 to that in 1999?
Your answer should be compact. 0.91. What is the ratio of the Value added (current US$) in Ireland in 1995 to that in 1999?
Your answer should be compact. 0.61. What is the ratio of the Value added (current US$) in Sub-Saharan Africa (developing only) in 1995 to that in 2000?
Your answer should be compact. 1.07. What is the ratio of the Value added (current US$) in Angola in 1995 to that in 2000?
Provide a short and direct response. 0.77. What is the ratio of the Value added (current US$) in Armenia in 1995 to that in 2000?
Your answer should be very brief. 1.11. What is the ratio of the Value added (current US$) in Ireland in 1995 to that in 2000?
Your answer should be compact. 0.62. What is the ratio of the Value added (current US$) of Sub-Saharan Africa (developing only) in 1995 to that in 2001?
Your answer should be compact. 1.13. What is the ratio of the Value added (current US$) in Angola in 1995 to that in 2001?
Offer a very short reply. 0.59. What is the ratio of the Value added (current US$) of Armenia in 1995 to that in 2001?
Offer a very short reply. 1.07. What is the ratio of the Value added (current US$) in Ireland in 1995 to that in 2001?
Make the answer very short. 0.52. What is the ratio of the Value added (current US$) of Sub-Saharan Africa (developing only) in 1996 to that in 1997?
Give a very brief answer. 0.97. What is the ratio of the Value added (current US$) in Angola in 1996 to that in 1997?
Your answer should be very brief. 0.77. What is the ratio of the Value added (current US$) in Armenia in 1996 to that in 1997?
Provide a succinct answer. 1.02. What is the ratio of the Value added (current US$) in Ireland in 1996 to that in 1997?
Your response must be concise. 0.86. What is the ratio of the Value added (current US$) of Sub-Saharan Africa (developing only) in 1996 to that in 1998?
Your answer should be compact. 1.04. What is the ratio of the Value added (current US$) in Angola in 1996 to that in 1998?
Your answer should be very brief. 0.64. What is the ratio of the Value added (current US$) of Armenia in 1996 to that in 1998?
Keep it short and to the point. 0.99. What is the ratio of the Value added (current US$) in Ireland in 1996 to that in 1998?
Ensure brevity in your answer.  0.74. What is the ratio of the Value added (current US$) in Sub-Saharan Africa (developing only) in 1996 to that in 1999?
Keep it short and to the point. 1.08. What is the ratio of the Value added (current US$) of Angola in 1996 to that in 1999?
Provide a succinct answer. 1.31. What is the ratio of the Value added (current US$) of Armenia in 1996 to that in 1999?
Your answer should be compact. 0.96. What is the ratio of the Value added (current US$) of Ireland in 1996 to that in 1999?
Offer a very short reply. 0.67. What is the ratio of the Value added (current US$) in Sub-Saharan Africa (developing only) in 1996 to that in 2000?
Offer a very short reply. 1.05. What is the ratio of the Value added (current US$) of Angola in 1996 to that in 2000?
Your answer should be compact. 0.98. What is the ratio of the Value added (current US$) in Armenia in 1996 to that in 2000?
Your response must be concise. 1.16. What is the ratio of the Value added (current US$) of Ireland in 1996 to that in 2000?
Ensure brevity in your answer.  0.67. What is the ratio of the Value added (current US$) in Sub-Saharan Africa (developing only) in 1996 to that in 2001?
Your response must be concise. 1.11. What is the ratio of the Value added (current US$) in Angola in 1996 to that in 2001?
Your answer should be compact. 0.75. What is the ratio of the Value added (current US$) of Armenia in 1996 to that in 2001?
Offer a terse response. 1.13. What is the ratio of the Value added (current US$) of Ireland in 1996 to that in 2001?
Keep it short and to the point. 0.56. What is the ratio of the Value added (current US$) in Sub-Saharan Africa (developing only) in 1997 to that in 1998?
Your response must be concise. 1.08. What is the ratio of the Value added (current US$) of Angola in 1997 to that in 1998?
Make the answer very short. 0.82. What is the ratio of the Value added (current US$) in Armenia in 1997 to that in 1998?
Provide a short and direct response. 0.98. What is the ratio of the Value added (current US$) of Ireland in 1997 to that in 1998?
Provide a short and direct response. 0.86. What is the ratio of the Value added (current US$) of Sub-Saharan Africa (developing only) in 1997 to that in 1999?
Offer a terse response. 1.12. What is the ratio of the Value added (current US$) in Angola in 1997 to that in 1999?
Give a very brief answer. 1.69. What is the ratio of the Value added (current US$) in Armenia in 1997 to that in 1999?
Offer a terse response. 0.94. What is the ratio of the Value added (current US$) of Ireland in 1997 to that in 1999?
Your answer should be very brief. 0.78. What is the ratio of the Value added (current US$) in Sub-Saharan Africa (developing only) in 1997 to that in 2000?
Offer a terse response. 1.08. What is the ratio of the Value added (current US$) of Angola in 1997 to that in 2000?
Offer a terse response. 1.27. What is the ratio of the Value added (current US$) of Armenia in 1997 to that in 2000?
Your response must be concise. 1.14. What is the ratio of the Value added (current US$) of Ireland in 1997 to that in 2000?
Offer a terse response. 0.78. What is the ratio of the Value added (current US$) of Sub-Saharan Africa (developing only) in 1997 to that in 2001?
Make the answer very short. 1.15. What is the ratio of the Value added (current US$) in Angola in 1997 to that in 2001?
Your answer should be compact. 0.97. What is the ratio of the Value added (current US$) of Armenia in 1997 to that in 2001?
Give a very brief answer. 1.11. What is the ratio of the Value added (current US$) of Ireland in 1997 to that in 2001?
Your response must be concise. 0.65. What is the ratio of the Value added (current US$) of Sub-Saharan Africa (developing only) in 1998 to that in 1999?
Your answer should be compact. 1.03. What is the ratio of the Value added (current US$) in Angola in 1998 to that in 1999?
Your answer should be compact. 2.05. What is the ratio of the Value added (current US$) of Armenia in 1998 to that in 1999?
Make the answer very short. 0.96. What is the ratio of the Value added (current US$) of Ireland in 1998 to that in 1999?
Provide a short and direct response. 0.9. What is the ratio of the Value added (current US$) of Sub-Saharan Africa (developing only) in 1998 to that in 2000?
Your answer should be compact. 1. What is the ratio of the Value added (current US$) of Angola in 1998 to that in 2000?
Provide a succinct answer. 1.54. What is the ratio of the Value added (current US$) in Armenia in 1998 to that in 2000?
Provide a short and direct response. 1.17. What is the ratio of the Value added (current US$) in Ireland in 1998 to that in 2000?
Offer a very short reply. 0.91. What is the ratio of the Value added (current US$) of Sub-Saharan Africa (developing only) in 1998 to that in 2001?
Make the answer very short. 1.06. What is the ratio of the Value added (current US$) of Angola in 1998 to that in 2001?
Offer a very short reply. 1.18. What is the ratio of the Value added (current US$) in Armenia in 1998 to that in 2001?
Provide a short and direct response. 1.13. What is the ratio of the Value added (current US$) in Ireland in 1998 to that in 2001?
Provide a succinct answer. 0.76. What is the ratio of the Value added (current US$) in Sub-Saharan Africa (developing only) in 1999 to that in 2000?
Provide a succinct answer. 0.97. What is the ratio of the Value added (current US$) in Angola in 1999 to that in 2000?
Your answer should be very brief. 0.75. What is the ratio of the Value added (current US$) of Armenia in 1999 to that in 2000?
Your answer should be compact. 1.21. What is the ratio of the Value added (current US$) in Ireland in 1999 to that in 2000?
Provide a succinct answer. 1.01. What is the ratio of the Value added (current US$) in Sub-Saharan Africa (developing only) in 1999 to that in 2001?
Your answer should be very brief. 1.03. What is the ratio of the Value added (current US$) of Angola in 1999 to that in 2001?
Your answer should be compact. 0.57. What is the ratio of the Value added (current US$) of Armenia in 1999 to that in 2001?
Provide a short and direct response. 1.18. What is the ratio of the Value added (current US$) in Ireland in 1999 to that in 2001?
Your answer should be very brief. 0.84. What is the ratio of the Value added (current US$) in Sub-Saharan Africa (developing only) in 2000 to that in 2001?
Offer a terse response. 1.06. What is the ratio of the Value added (current US$) of Angola in 2000 to that in 2001?
Offer a very short reply. 0.76. What is the ratio of the Value added (current US$) in Armenia in 2000 to that in 2001?
Ensure brevity in your answer.  0.97. What is the ratio of the Value added (current US$) of Ireland in 2000 to that in 2001?
Make the answer very short. 0.84. What is the difference between the highest and the second highest Value added (current US$) in Sub-Saharan Africa (developing only)?
Offer a very short reply. 7.05e+08. What is the difference between the highest and the second highest Value added (current US$) in Angola?
Your answer should be compact. 6.12e+07. What is the difference between the highest and the second highest Value added (current US$) of Armenia?
Keep it short and to the point. 1.38e+07. What is the difference between the highest and the second highest Value added (current US$) in Ireland?
Provide a succinct answer. 4.31e+09. What is the difference between the highest and the lowest Value added (current US$) in Sub-Saharan Africa (developing only)?
Ensure brevity in your answer.  6.16e+09. What is the difference between the highest and the lowest Value added (current US$) of Angola?
Make the answer very short. 2.09e+08. What is the difference between the highest and the lowest Value added (current US$) of Armenia?
Offer a very short reply. 6.86e+07. What is the difference between the highest and the lowest Value added (current US$) in Ireland?
Ensure brevity in your answer.  1.33e+1. 